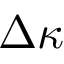<formula> <loc_0><loc_0><loc_500><loc_500>\Delta \kappa</formula> 